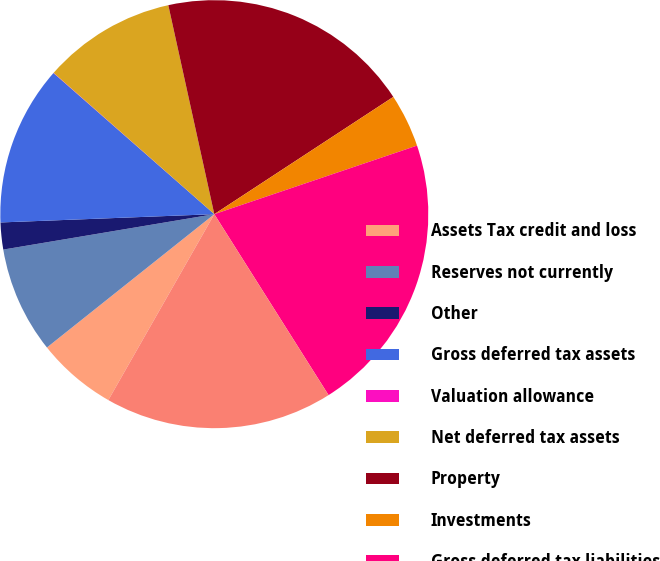Convert chart to OTSL. <chart><loc_0><loc_0><loc_500><loc_500><pie_chart><fcel>Assets Tax credit and loss<fcel>Reserves not currently<fcel>Other<fcel>Gross deferred tax assets<fcel>Valuation allowance<fcel>Net deferred tax assets<fcel>Property<fcel>Investments<fcel>Gross deferred tax liabilities<fcel>Net deferred tax liability<nl><fcel>6.05%<fcel>8.06%<fcel>2.03%<fcel>12.08%<fcel>0.02%<fcel>10.07%<fcel>19.22%<fcel>4.04%<fcel>21.23%<fcel>17.21%<nl></chart> 